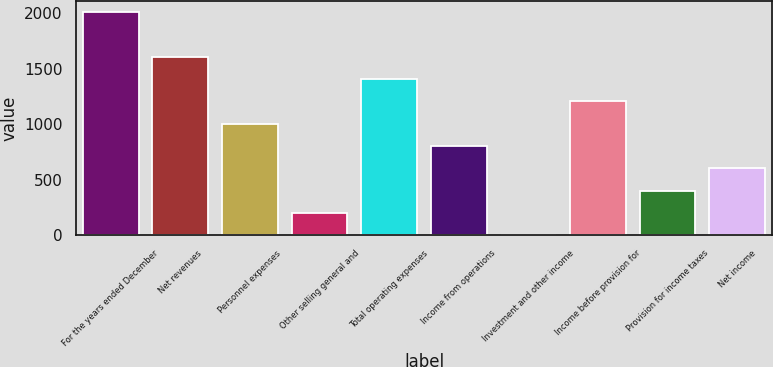<chart> <loc_0><loc_0><loc_500><loc_500><bar_chart><fcel>For the years ended December<fcel>Net revenues<fcel>Personnel expenses<fcel>Other selling general and<fcel>Total operating expenses<fcel>Income from operations<fcel>Investment and other income<fcel>Income before provision for<fcel>Provision for income taxes<fcel>Net income<nl><fcel>2011<fcel>1608.82<fcel>1005.55<fcel>201.19<fcel>1407.73<fcel>804.46<fcel>0.1<fcel>1206.64<fcel>402.28<fcel>603.37<nl></chart> 